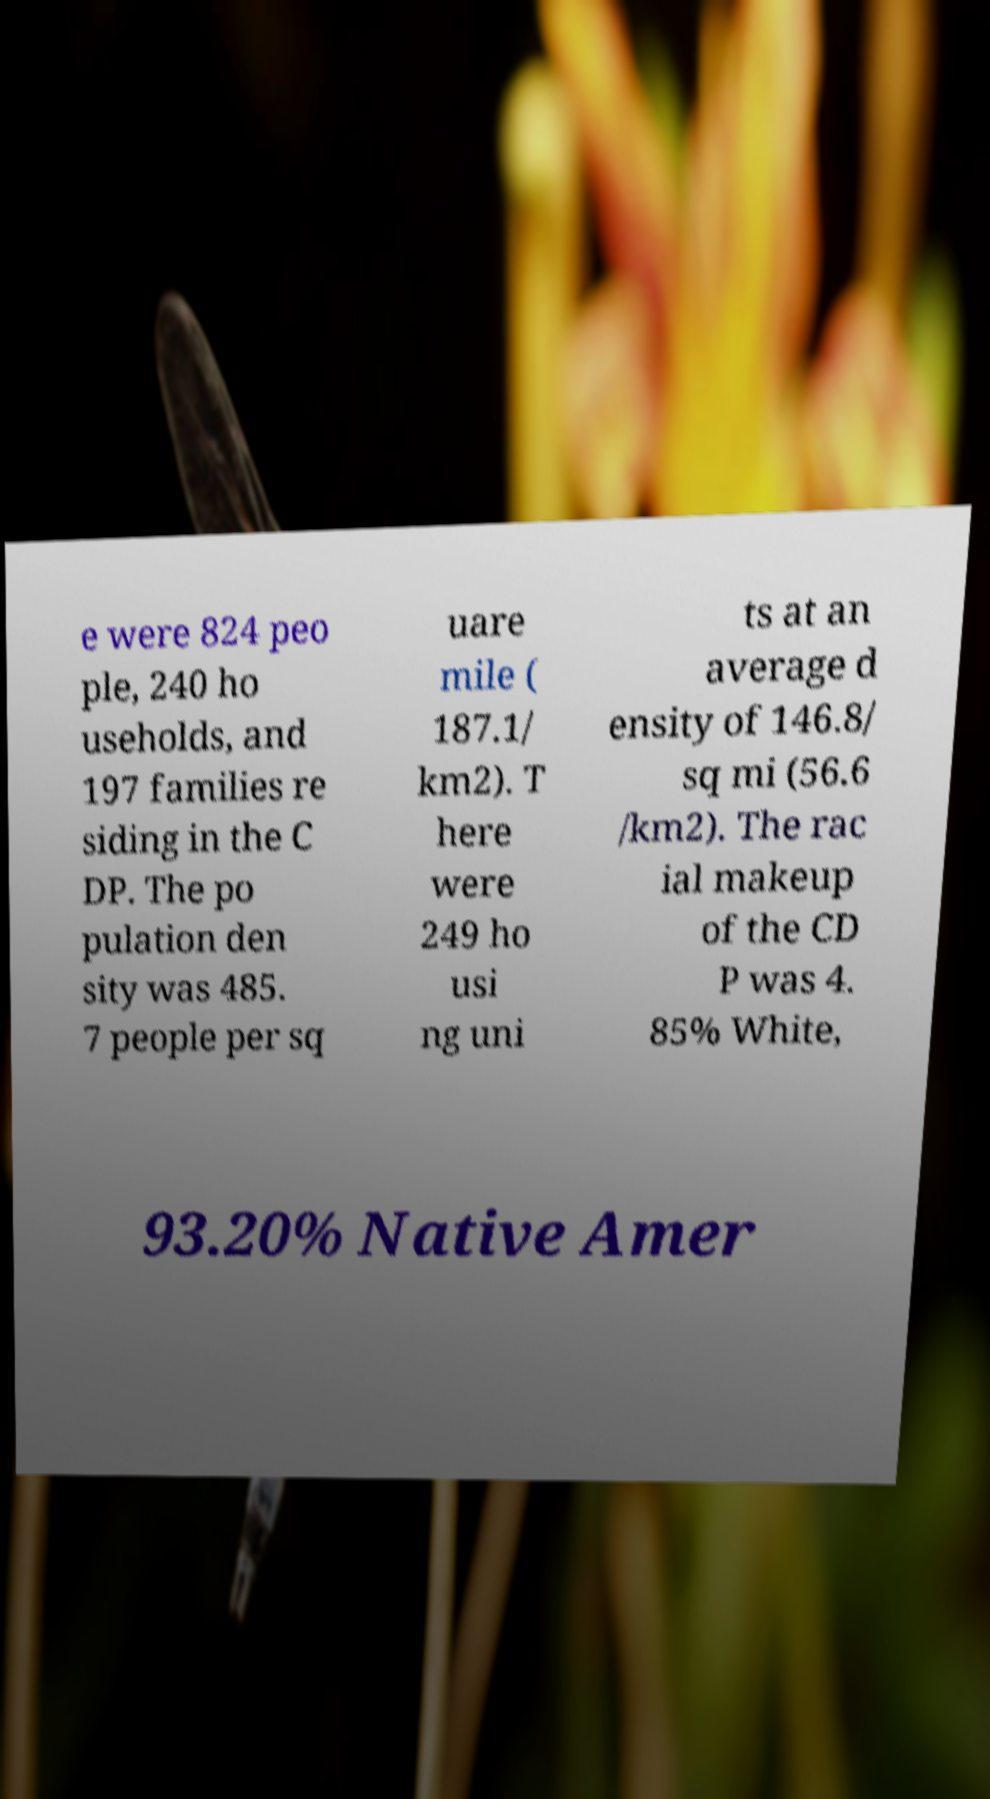Could you assist in decoding the text presented in this image and type it out clearly? e were 824 peo ple, 240 ho useholds, and 197 families re siding in the C DP. The po pulation den sity was 485. 7 people per sq uare mile ( 187.1/ km2). T here were 249 ho usi ng uni ts at an average d ensity of 146.8/ sq mi (56.6 /km2). The rac ial makeup of the CD P was 4. 85% White, 93.20% Native Amer 